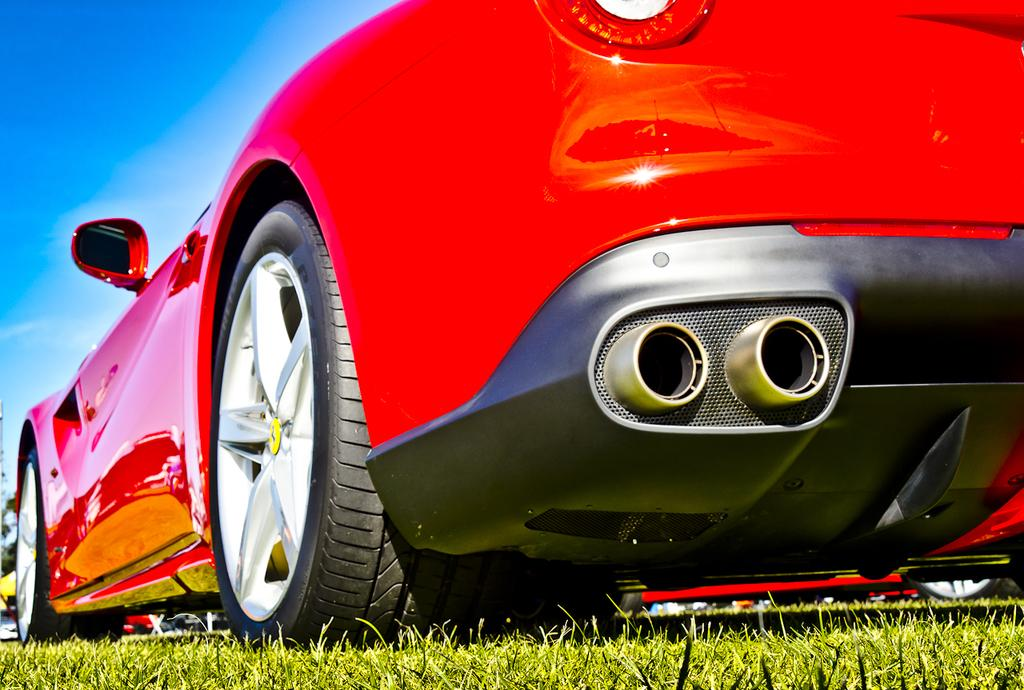What color is the car in the image? The car in the image is red. Where is the car located in the image? The car is on the ground in the image. What type of vegetation is present on the ground? There is grass on the ground in the image. What else can be seen on the surface in the image? There are objects on the surface in the image. What is visible at the top of the image? The sky is visible at the top of the image. How many children are playing with the pump in the image? There are no children or pumps present in the image. 